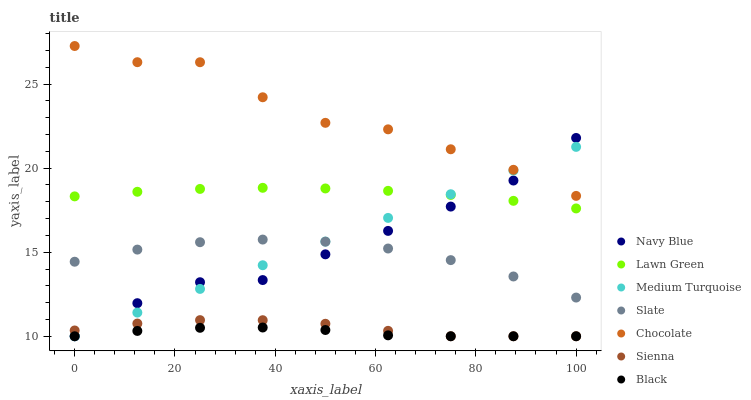Does Black have the minimum area under the curve?
Answer yes or no. Yes. Does Chocolate have the maximum area under the curve?
Answer yes or no. Yes. Does Navy Blue have the minimum area under the curve?
Answer yes or no. No. Does Navy Blue have the maximum area under the curve?
Answer yes or no. No. Is Medium Turquoise the smoothest?
Answer yes or no. Yes. Is Chocolate the roughest?
Answer yes or no. Yes. Is Navy Blue the smoothest?
Answer yes or no. No. Is Navy Blue the roughest?
Answer yes or no. No. Does Navy Blue have the lowest value?
Answer yes or no. Yes. Does Slate have the lowest value?
Answer yes or no. No. Does Chocolate have the highest value?
Answer yes or no. Yes. Does Navy Blue have the highest value?
Answer yes or no. No. Is Black less than Chocolate?
Answer yes or no. Yes. Is Lawn Green greater than Black?
Answer yes or no. Yes. Does Navy Blue intersect Sienna?
Answer yes or no. Yes. Is Navy Blue less than Sienna?
Answer yes or no. No. Is Navy Blue greater than Sienna?
Answer yes or no. No. Does Black intersect Chocolate?
Answer yes or no. No. 